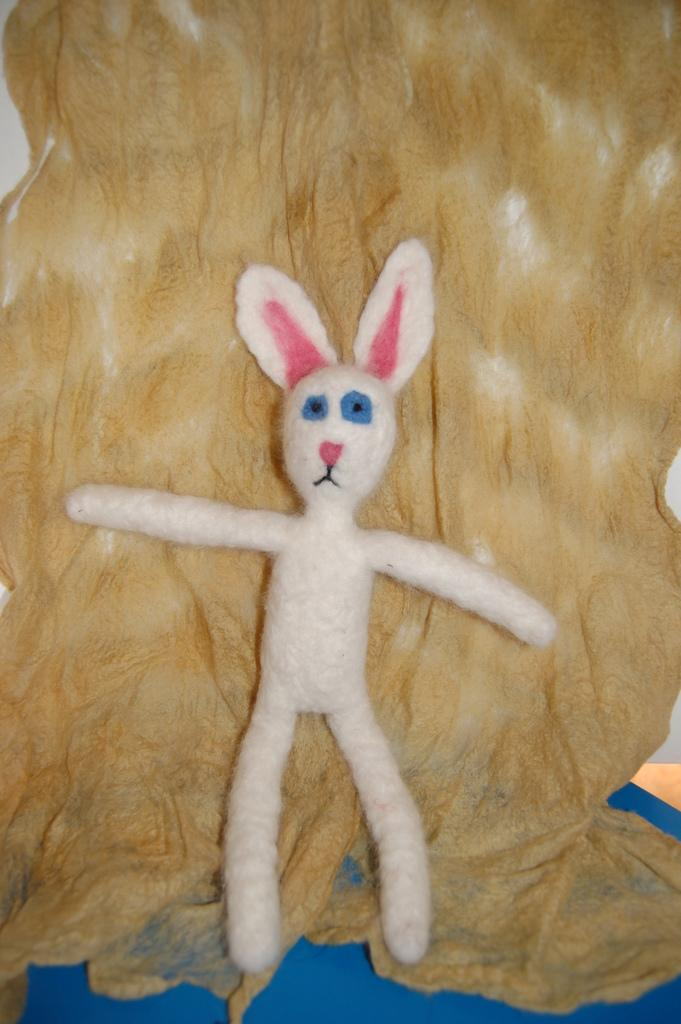What is the main object in the image? There is a soft toy in the image. What is the soft toy placed on? The soft toy is placed on a cloth. What type of print can be seen on the queen's dress in the image? There is no queen or dress present in the image; it features a soft toy placed on a cloth. How many bikes are visible in the image? There are no bikes present in the image. 